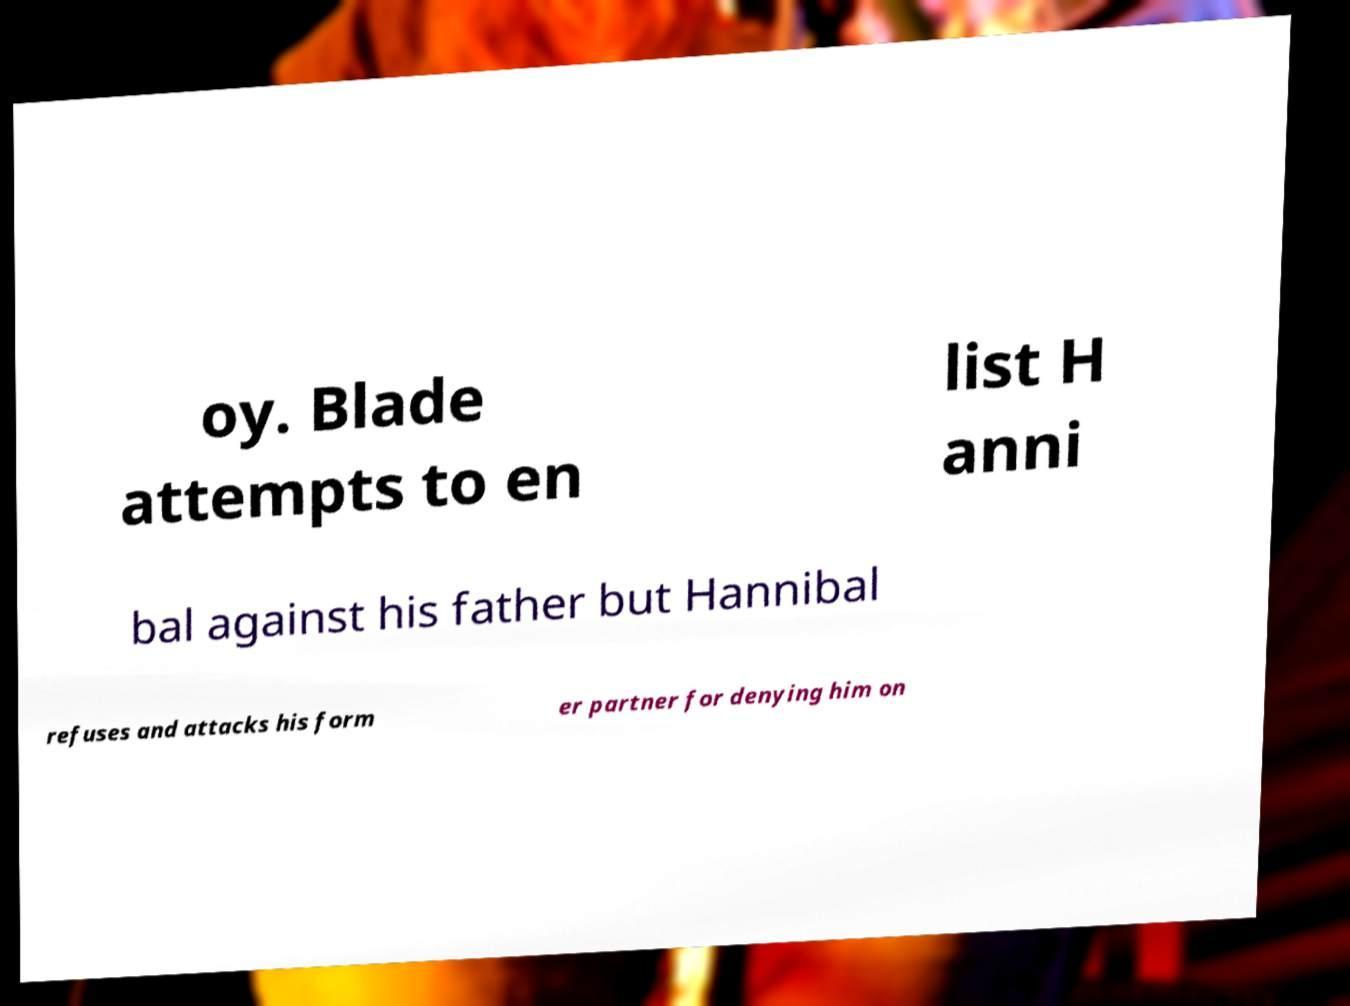Could you extract and type out the text from this image? oy. Blade attempts to en list H anni bal against his father but Hannibal refuses and attacks his form er partner for denying him on 